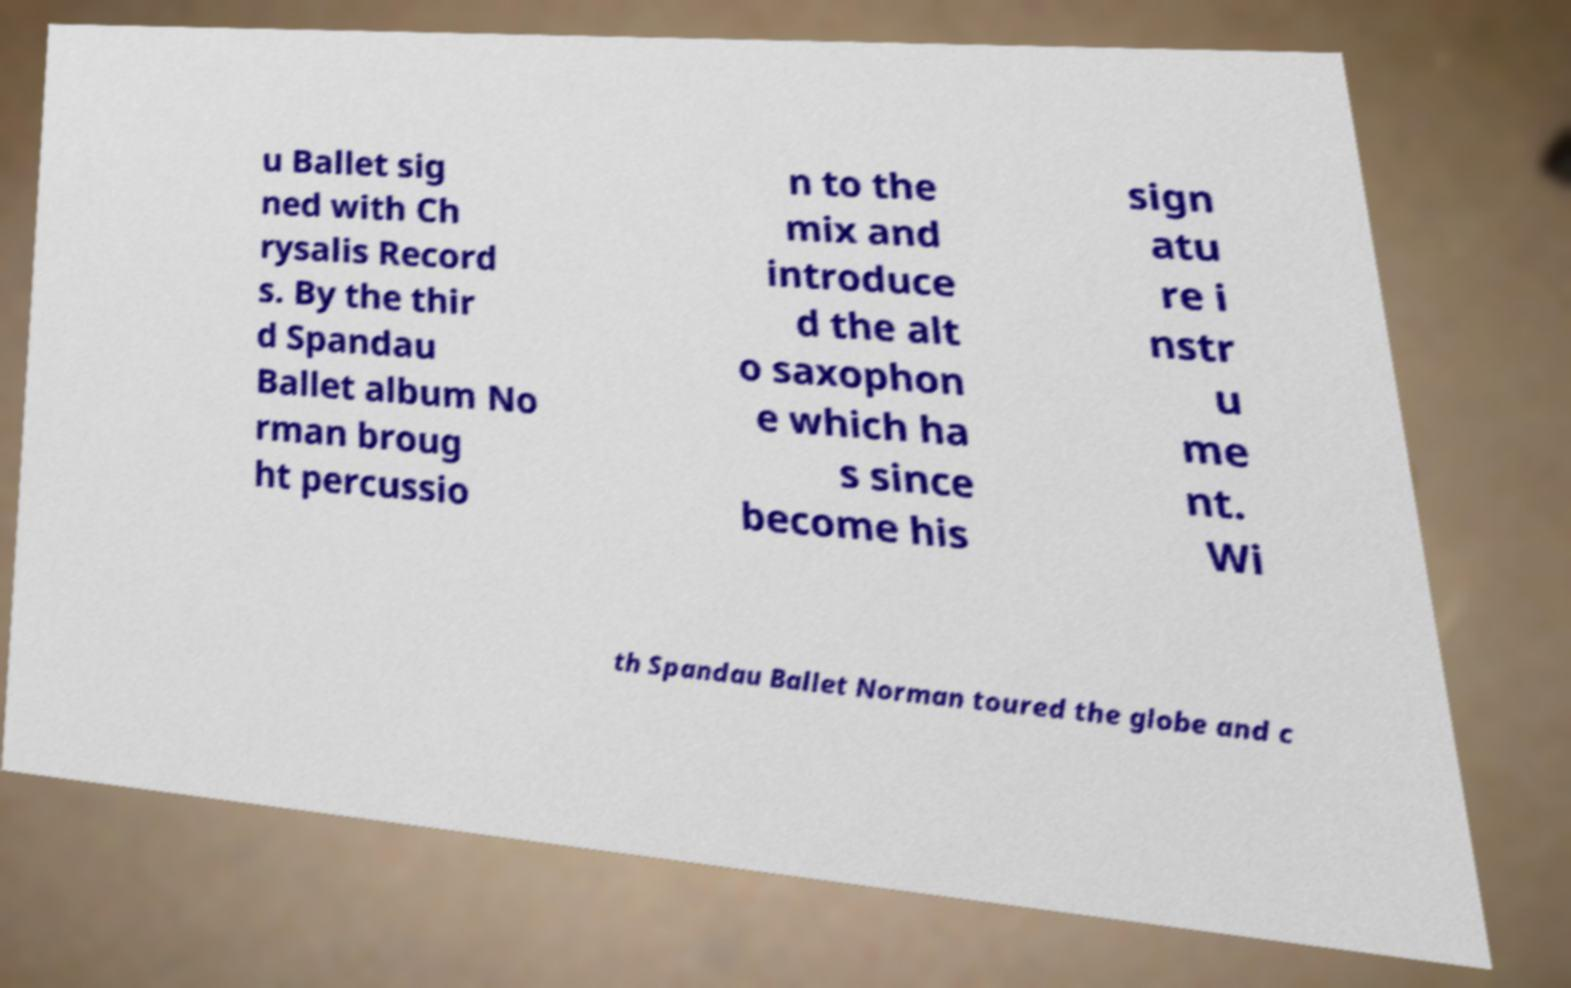Can you accurately transcribe the text from the provided image for me? u Ballet sig ned with Ch rysalis Record s. By the thir d Spandau Ballet album No rman broug ht percussio n to the mix and introduce d the alt o saxophon e which ha s since become his sign atu re i nstr u me nt. Wi th Spandau Ballet Norman toured the globe and c 